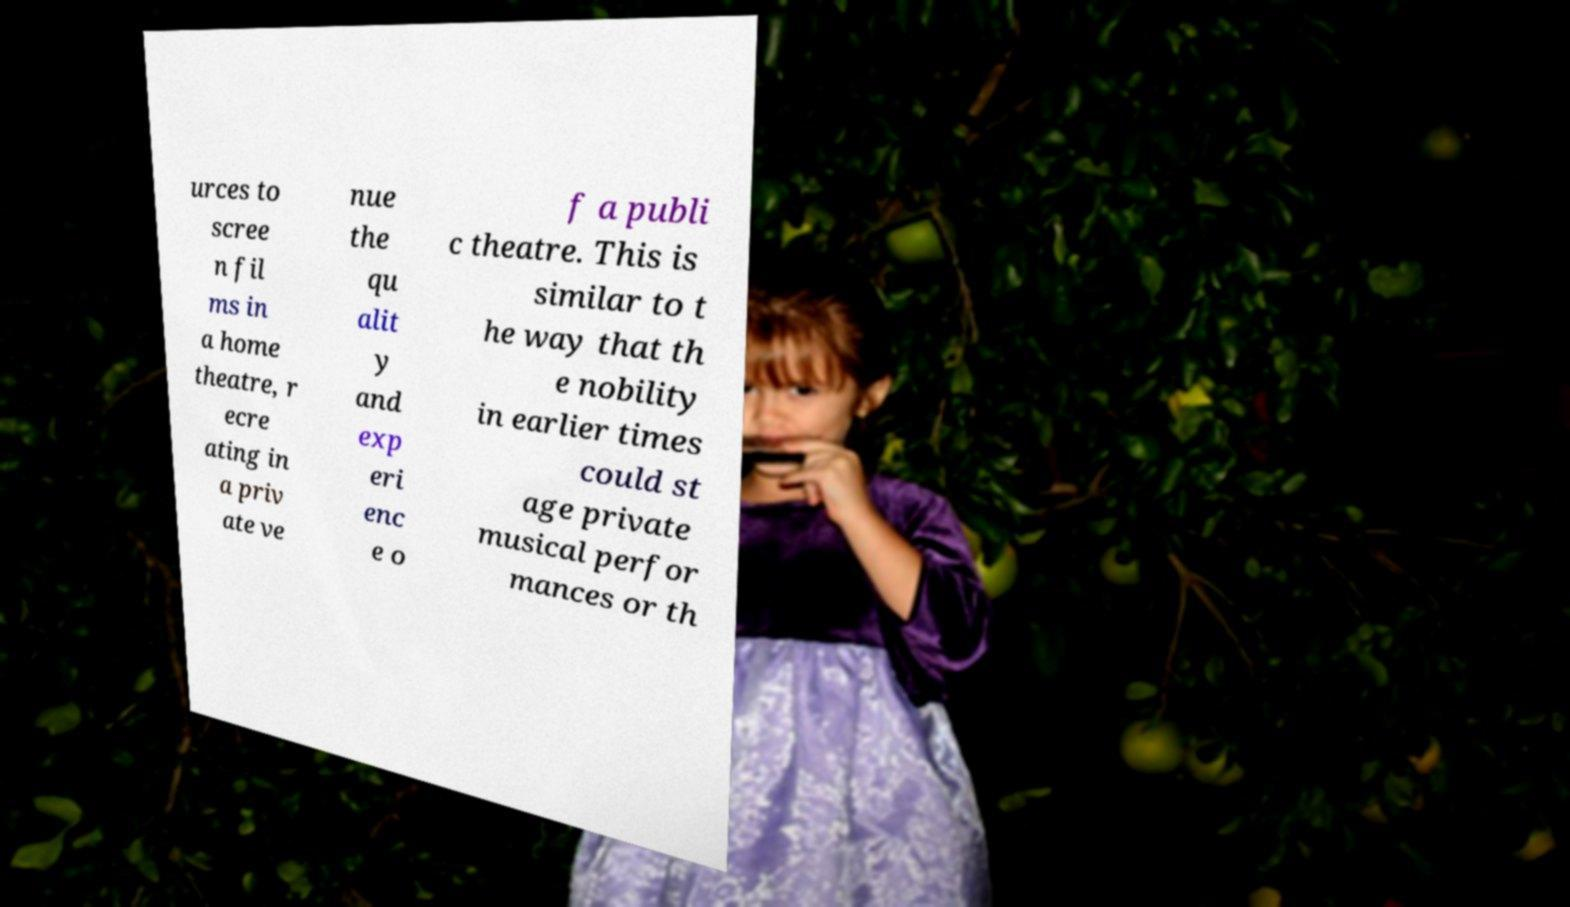What messages or text are displayed in this image? I need them in a readable, typed format. urces to scree n fil ms in a home theatre, r ecre ating in a priv ate ve nue the qu alit y and exp eri enc e o f a publi c theatre. This is similar to t he way that th e nobility in earlier times could st age private musical perfor mances or th 